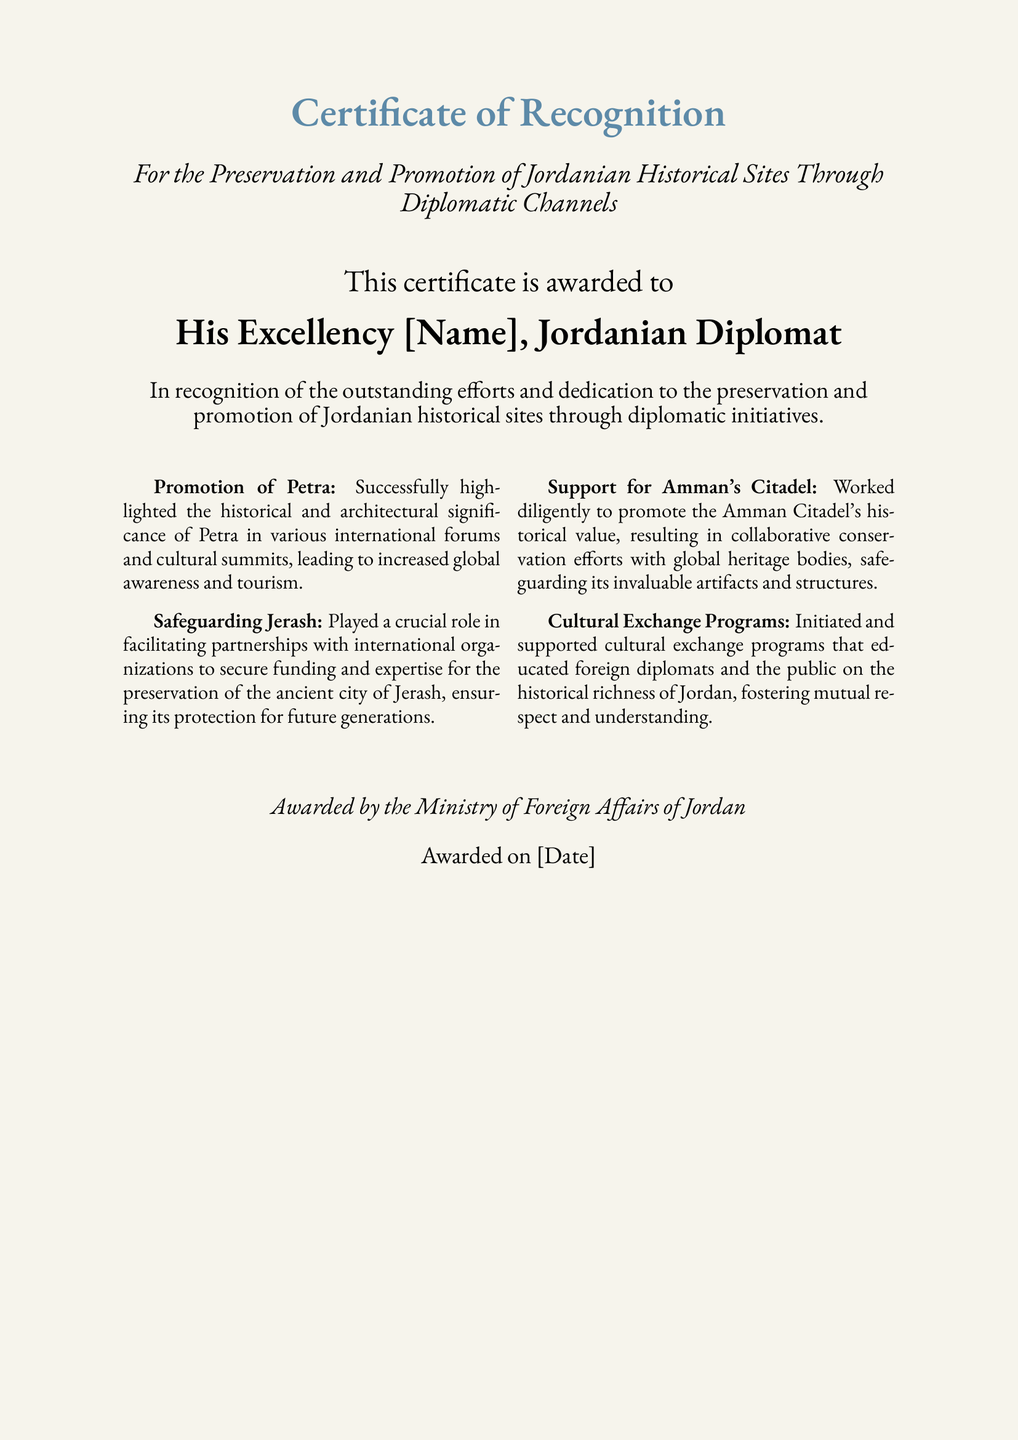What is the title of the certificate? The title can be found at the top of the document and indicates the purpose of the recognition.
Answer: Certificate of Recognition Who is the certificate awarded to? The document specifies the recipient's title and role, providing clear information about the awardee.
Answer: His Excellency [Name], Jordanian Diplomat What is the date of the award? The date is mentioned towards the end of the document, indicating when the certificate was issued.
Answer: [Date] Which historical site is highlighted for global awareness? This information is presented in the promotion section, emphasizing the importance of a specific historical site.
Answer: Petra What organization awarded the certificate? The awarding body is stated at the bottom of the document, showing the authority behind the recognition.
Answer: Ministry of Foreign Affairs of Jordan How did the diplomat contribute to Jerash? This contribution is detailed in a section that discusses the diplomat's efforts in securing funding and expertise for a specific site.
Answer: Facilitating partnerships with international organizations What type of programs did the diplomat initiate? The document outlines a specific initiative aimed at educating others about Jordan's history, demonstrating the diplomat's engagement in cultural efforts.
Answer: Cultural Exchange Programs What is the significance of the Amman Citadel according to the document? The significance is mentioned in relation to conservation efforts and the promotion of its historical value.
Answer: Historical value How many sections describe the contributions made? The contributions made by the diplomat are organized into a singular format, indicating a specific structure for the achievements mentioned.
Answer: Four 